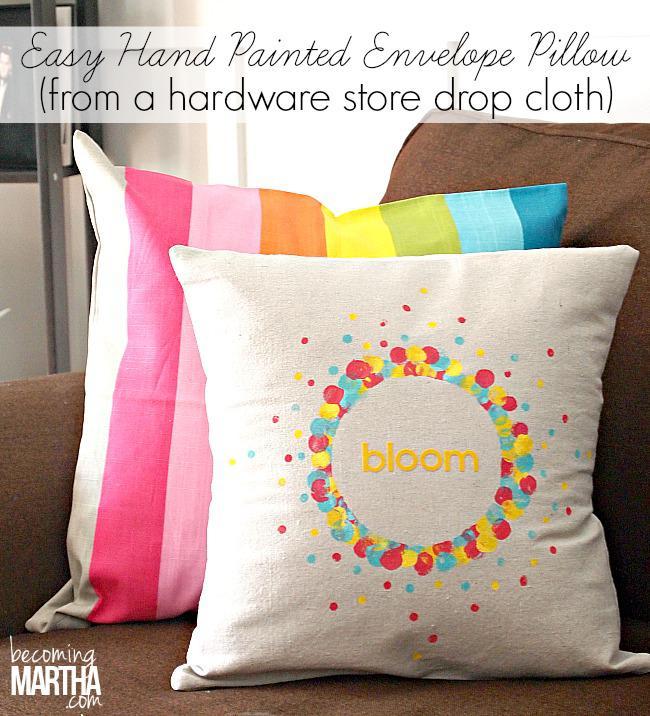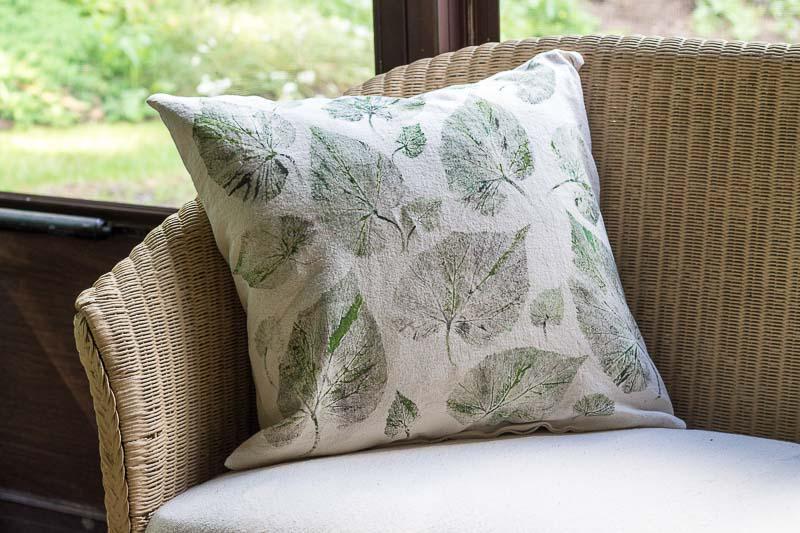The first image is the image on the left, the second image is the image on the right. Examine the images to the left and right. Is the description "A square pillow with dark stripes down the middle is overlapping another pillow with stripes and displayed on a woodgrain surface, in the right image." accurate? Answer yes or no. No. The first image is the image on the left, the second image is the image on the right. For the images displayed, is the sentence "There are two white pillows one in the back with two small strips pattern that repeat itself and a top pillow with 3 strips with the middle being the biggest." factually correct? Answer yes or no. No. 